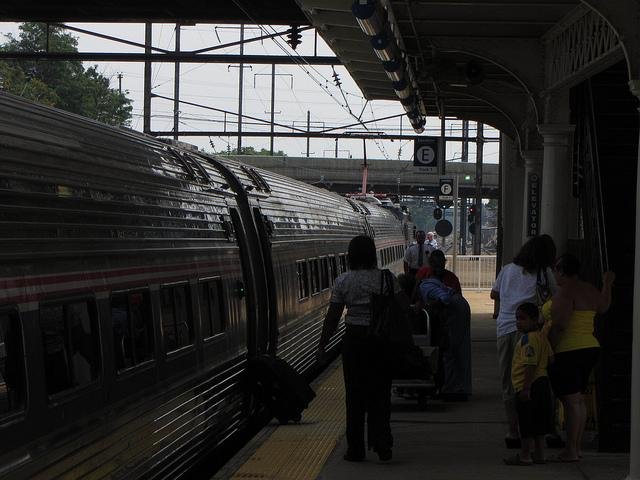What sort of power moves this vehicle?

Choices:
A) electric
B) diesel
C) gas
D) coal electric 